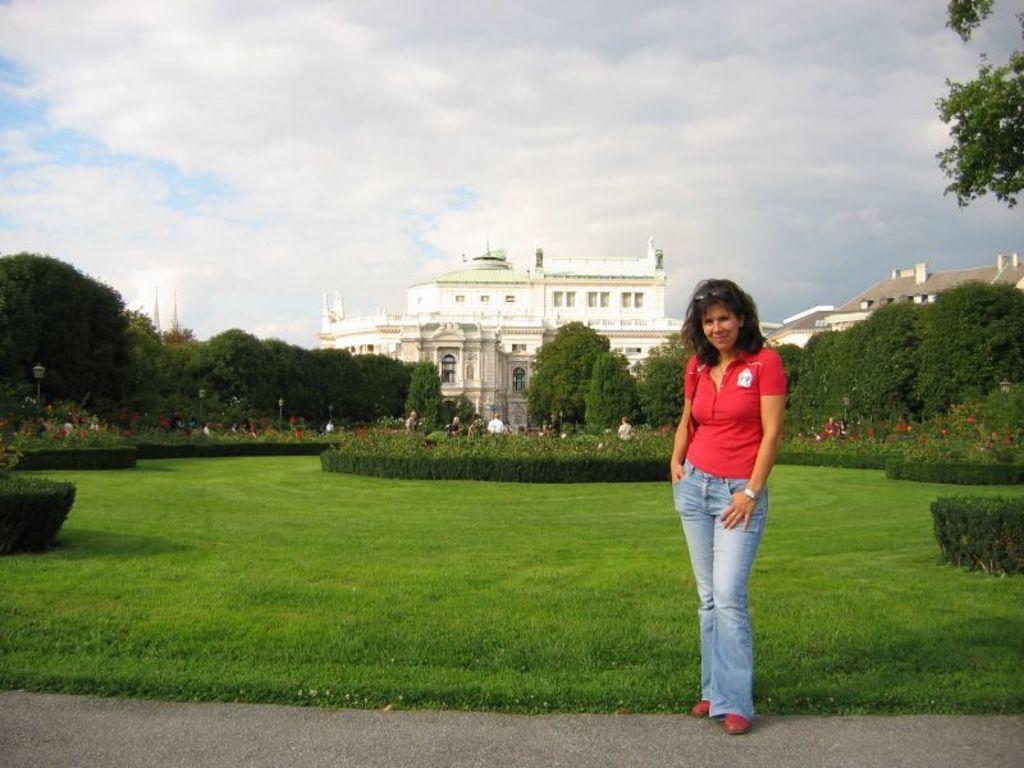Please provide a concise description of this image. In this image there is a woman standing with a smile on her face is posing for the camera, behind the woman there are a few people standing on the grass and there are bushes, trees and buildings. 